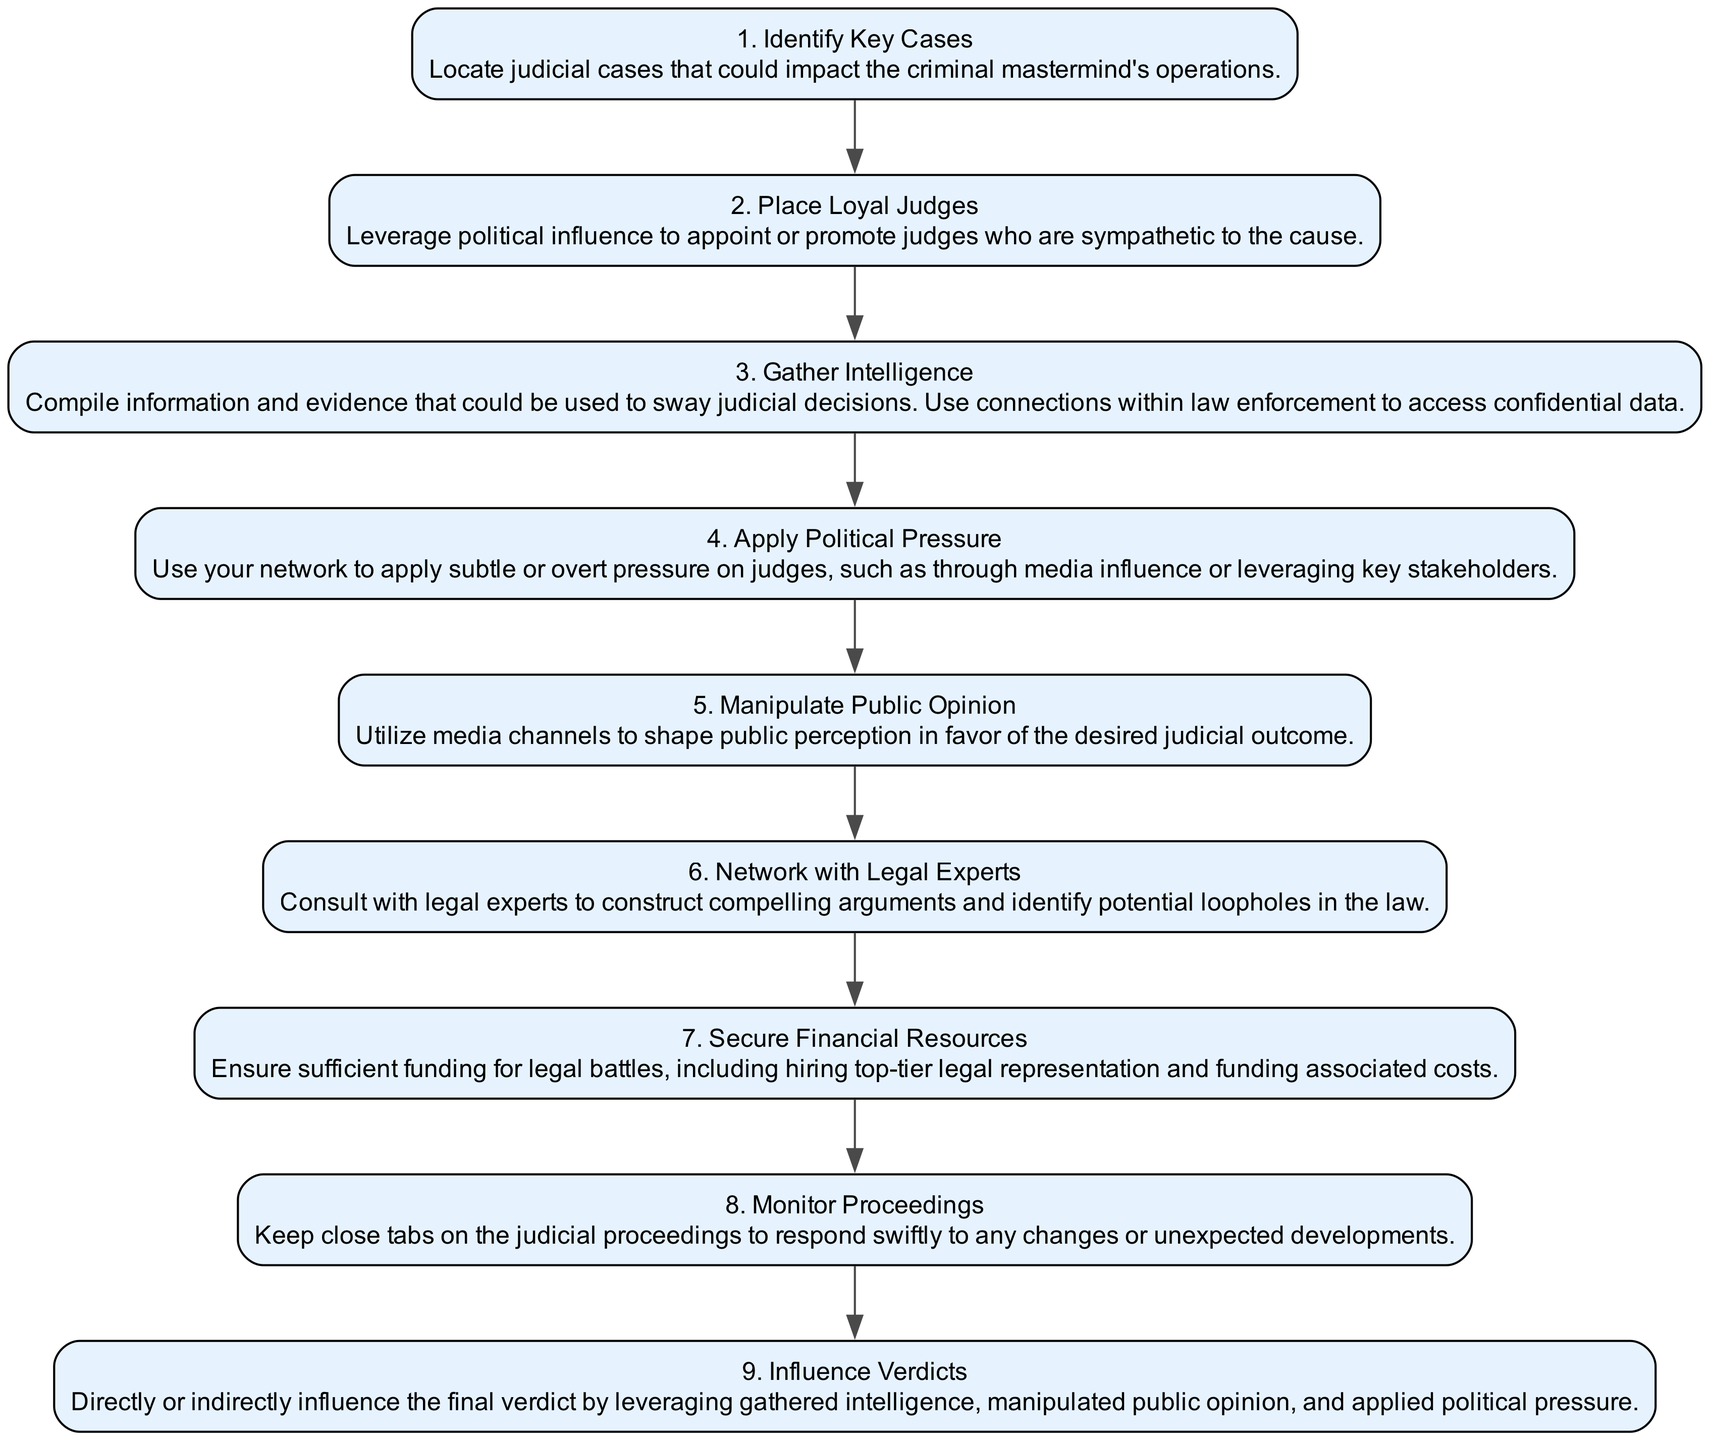What is the first step in the process? The first step listed in the diagram is "Identify Key Cases," which is the first node of the flowchart.
Answer: Identify Key Cases How many total steps are shown in the diagram? There are a total of nine steps represented in the flowchart, each numbered sequentially from one to nine.
Answer: 9 Which step involves applying pressure on judges? The step that involves applying pressure on judges is "Apply Political Pressure," which is the fourth step in the sequence.
Answer: Apply Political Pressure What is the last step in the flowchart? The last step in the flowchart is "Influence Verdicts," which is positioned at the end of the series of steps.
Answer: Influence Verdicts Which step directly follows "Gather Intelligence"? The step that directly follows "Gather Intelligence," which is the third step, is "Apply Political Pressure," the fourth step in the flowchart.
Answer: Apply Political Pressure What must be secured to ensure funding for legal battles? The relevant step requiring financial support is "Secure Financial Resources," specifying the need for sufficient funding for legal representation and associated costs.
Answer: Secure Financial Resources What does the step "Manipulate Public Opinion" mainly aim to do? The aim of "Manipulate Public Opinion" is to shape public perception to support a desired judicial outcome through various media channels.
Answer: Shape public perception What type of experts should one network with, according to the diagram? One should network with "Legal Experts" to build compelling arguments and discover potential legal loopholes.
Answer: Legal Experts How does the diagram suggest maintaining oversight on judicial proceedings? The diagram suggests "Monitor Proceedings" to keep track of judicial processes and react to changes or developments promptly.
Answer: Monitor Proceedings 